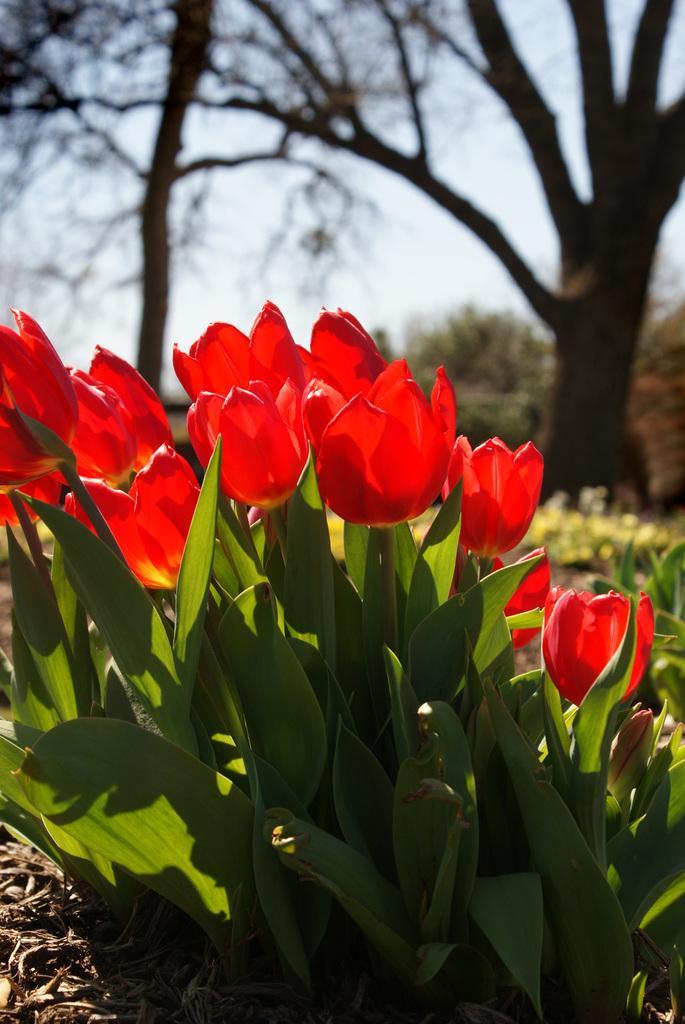Can you describe this image briefly? In front of the image there are plants and flowers. In the background of the image there are trees. At the top of the image there is sky. 